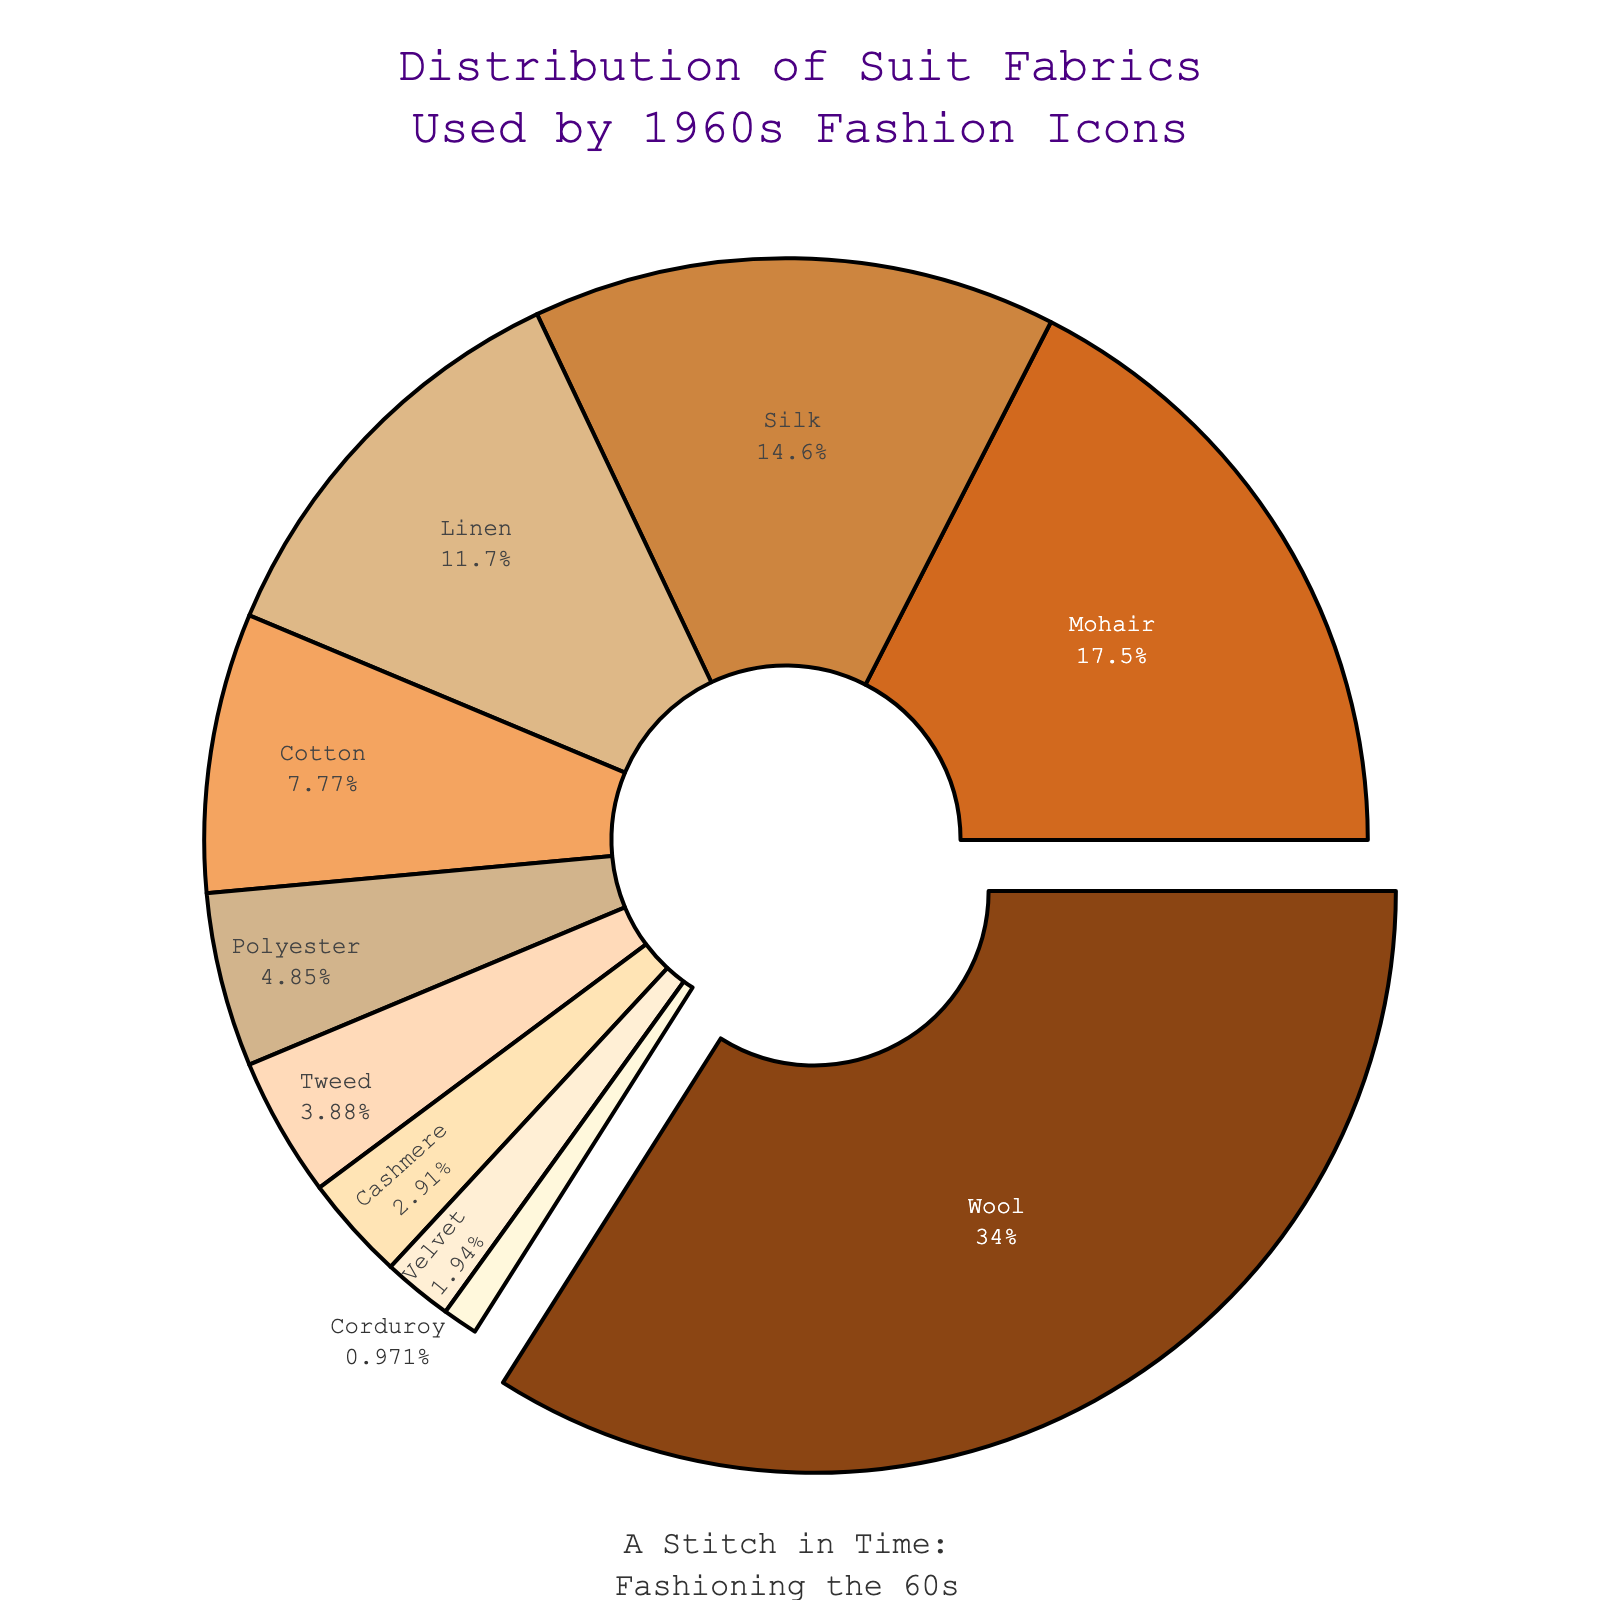What is the most commonly used fabric by fashion icons in the 1960s? The pie chart shows that the largest segment is "Wool," which is visually pulled out from the rest of the chart. This indicates that Wool has the highest percentage.
Answer: Wool What percentage of the suit fabrics is made up by the top two fabrics? The two largest segments are "Wool" (35%) and "Mohair" (18%). Adding these percentages together, 35 + 18 = 53.
Answer: 53% How many fabrics make up less than 10% each of the overall use? The pie chart segments for "Cotton" (8%), "Polyester" (5%), "Tweed" (4%), "Cashmere" (3%), "Velvet" (2%), and "Corduroy" (1%) all are less than 10%. Counting these, 6 fabrics have less than 10% each.
Answer: 6 Which fabric is used more: Silk or Linen? The pie chart shows that Silk has a slightly larger segment than Linen. Silk represents 15% whereas Linen represents 12%.
Answer: Silk What is the combined percentage of fabrics other than Wool, Mohair, and Silk? The total percentage for these three fabrics is Wool (35%) + Mohair (18%) + Silk (15%) = 68%. Subtracting this from 100%, we get 100 - 68 = 32%.
Answer: 32% Is Cashmere used more than Tweed? The pie chart shows that Tweed has a segment of 4%, while Cashmere has a smaller segment of 3%.
Answer: No What's the difference in usage percentage between Cotton and Polyester? The Cotton segment is 8%, and the Polyester segment is 5%. Subtracting these, 8 - 5 = 3%.
Answer: 3% What fabric makes up exactly 1% of the distribution? The pie chart shows a small segment labeled "Corduroy," which is listed as 1%.
Answer: Corduroy Which fabric segment is colored with the lightest shade visible? The pie chart shows that the "Corduroy" segment, which is 1%, appears in the lightest shade among all the segments.
Answer: Corduroy How much less popular is Velvet compared to Mohair? Velvet has a segment of 2%, while Mohair has a segment of 18%. Subtracting these, 18 - 2 = 16%.
Answer: 16% 